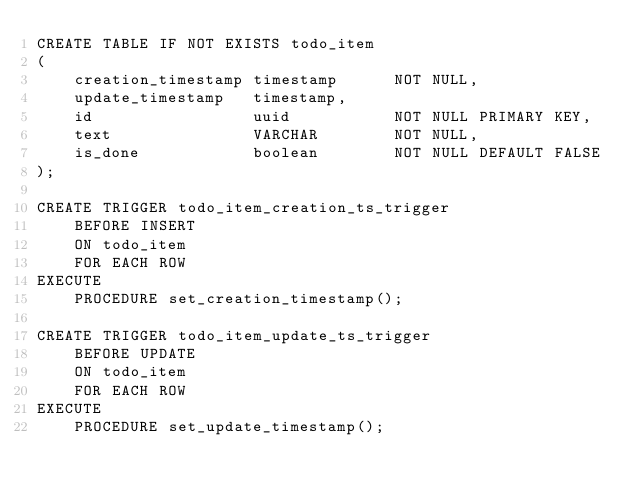Convert code to text. <code><loc_0><loc_0><loc_500><loc_500><_SQL_>CREATE TABLE IF NOT EXISTS todo_item
(
    creation_timestamp timestamp      NOT NULL,
    update_timestamp   timestamp,
    id                 uuid           NOT NULL PRIMARY KEY,
    text               VARCHAR        NOT NULL,
    is_done            boolean        NOT NULL DEFAULT FALSE
);

CREATE TRIGGER todo_item_creation_ts_trigger
    BEFORE INSERT
    ON todo_item
    FOR EACH ROW
EXECUTE
    PROCEDURE set_creation_timestamp();

CREATE TRIGGER todo_item_update_ts_trigger
    BEFORE UPDATE
    ON todo_item
    FOR EACH ROW
EXECUTE
    PROCEDURE set_update_timestamp();</code> 